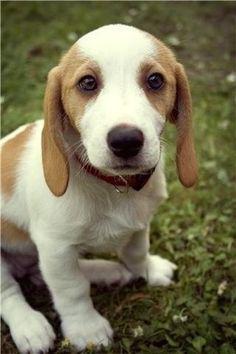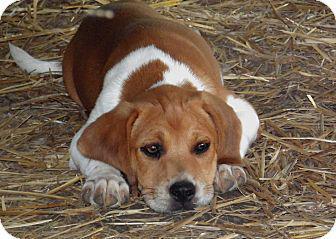The first image is the image on the left, the second image is the image on the right. Assess this claim about the two images: "There are no less than three beagle puppies". Correct or not? Answer yes or no. No. The first image is the image on the left, the second image is the image on the right. Given the left and right images, does the statement "The left image contains at least two dogs." hold true? Answer yes or no. No. 